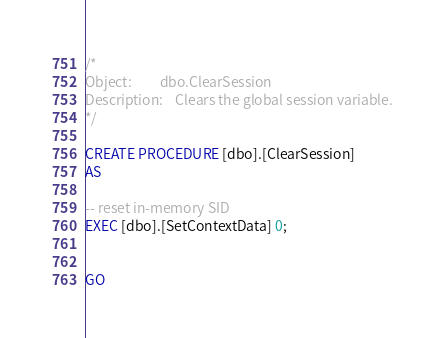Convert code to text. <code><loc_0><loc_0><loc_500><loc_500><_SQL_>
/*
Object:			dbo.ClearSession
Description:	Clears the global session variable.
*/

CREATE PROCEDURE [dbo].[ClearSession]
AS 

-- reset in-memory SID
EXEC [dbo].[SetContextData] 0;


GO


</code> 